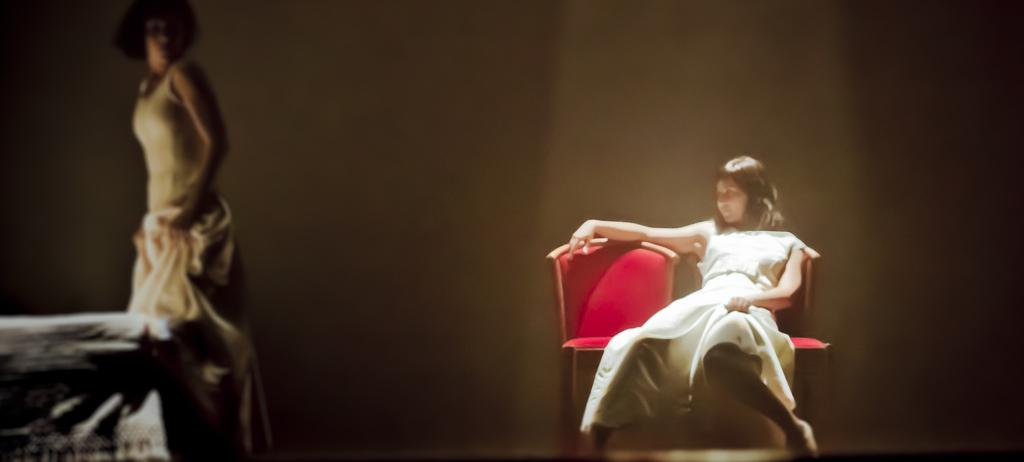What is the position of the first woman in the image? There is a woman sitting on a chair in the image. What is the position of the second woman in the image? There is a woman standing in the image. What are the women wearing? Both women are wearing white dresses. What color is the chair the first woman is sitting on? The chair is red. What type of record is being played by the woman in the image? There is no record or music player present in the image, so it cannot be determined if a record is being played. 